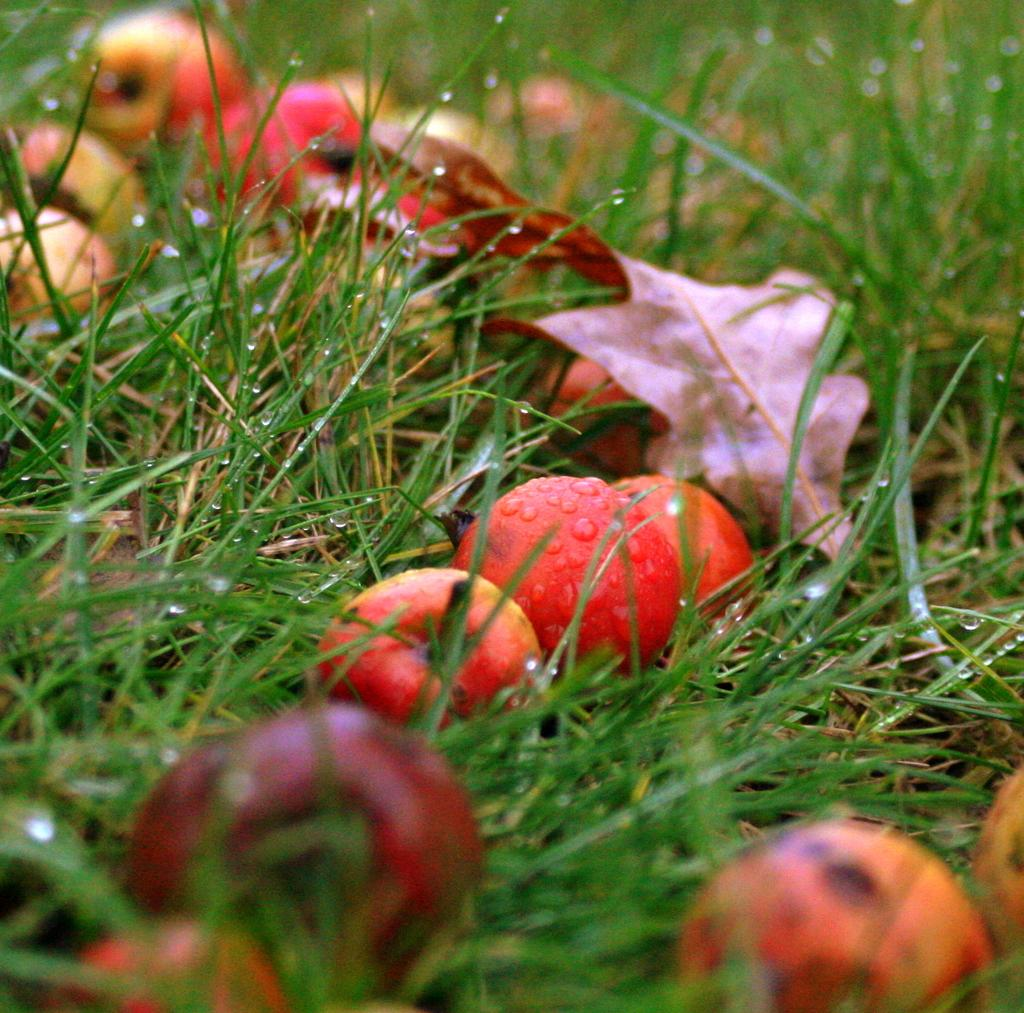What type of food can be seen in the image? There are fruits in the image. What type of vegetation is visible in the image? There is grass visible in the image. What type of thrill can be experienced while eating the fruits in the image? The image does not convey any information about a thrill associated with eating the fruits. 